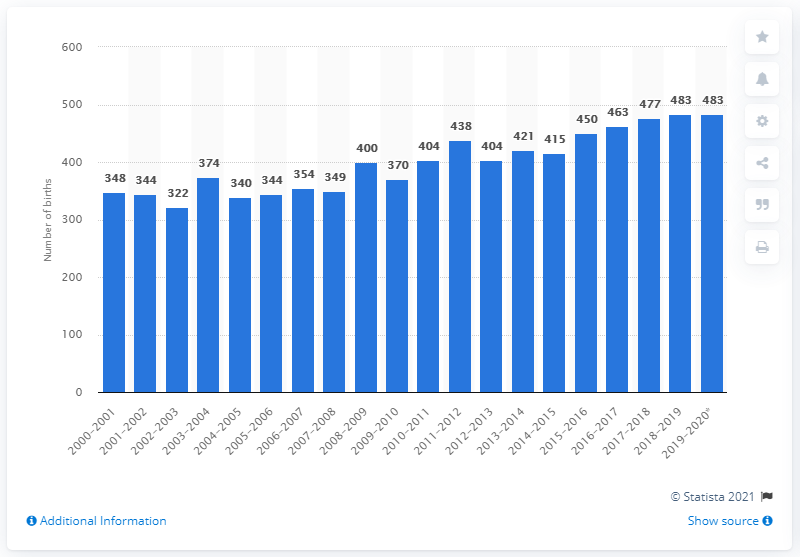Give some essential details in this illustration. Between July 1, 2019 and June 30, 2020, a total of 483 people were born in Yukon. 